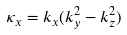<formula> <loc_0><loc_0><loc_500><loc_500>\kappa _ { x } = k _ { x } ( k _ { y } ^ { 2 } - k _ { z } ^ { 2 } )</formula> 